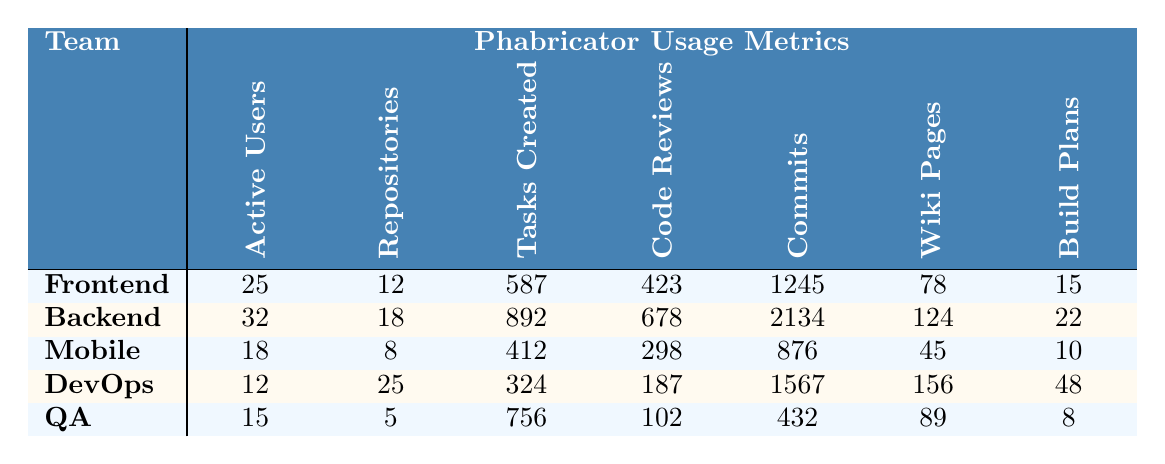What is the number of active users in the Backend team? The Backend team has 32 active users listed in the table.
Answer: 32 Which team has the highest number of repositories? The DevOps team has 25 repositories, which is the highest among all teams.
Answer: DevOps What is the total number of tasks created by all teams combined? Adding the tasks created by all teams: 587 + 892 + 412 + 324 + 756 = 2971.
Answer: 2971 Is the number of code reviews conducted by the Mobile team greater than that of the QA team? The Mobile team has 298 code reviews, while the QA team has 102. Since 298 is greater than 102, the statement is true.
Answer: Yes Which team has the lowest number of active users? The DevOps team has the least active users with a count of 12 according to the table.
Answer: DevOps What is the average number of commits across all teams? First, sum the number of commits: 1245 + 2134 + 876 + 1567 + 432 = 6254. There are 5 teams, so the average is 6254 / 5 = 1250.8.
Answer: 1250.8 How many more tasks were created by the Backend team compared to the Mobile team? The Backend team created 892 tasks, and the Mobile team created 412 tasks. The difference is 892 - 412 = 480.
Answer: 480 Is it true that the QA team has more Wiki pages than the Mobile team? The QA team has 89 Wiki pages, and the Mobile team has 45. Since 89 is greater than 45, the statement is true.
Answer: Yes What is the relationship between the number of commits and active users for the Frontend team? The Frontend team has 25 active users and 1245 commits. The relationship is that more active users usually lead to more commits, and in this case, the Frontend team has a high number of commits relative to its active users.
Answer: 1245 commits to 25 active users Which team produced the least number of code reviews? The QA team conducted 102 code reviews, which is the least compared to other teams' figures in the table.
Answer: QA 